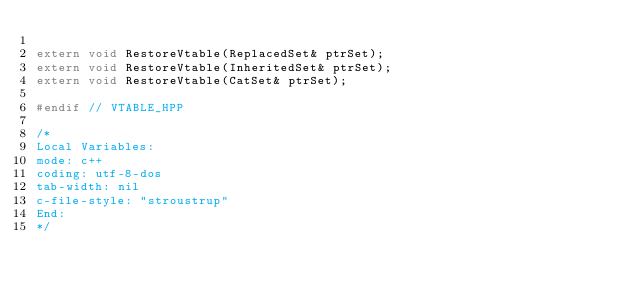<code> <loc_0><loc_0><loc_500><loc_500><_C++_>
extern void RestoreVtable(ReplacedSet& ptrSet);
extern void RestoreVtable(InheritedSet& ptrSet);
extern void RestoreVtable(CatSet& ptrSet);

#endif // VTABLE_HPP

/*
Local Variables:
mode: c++
coding: utf-8-dos
tab-width: nil
c-file-style: "stroustrup"
End:
*/
</code> 